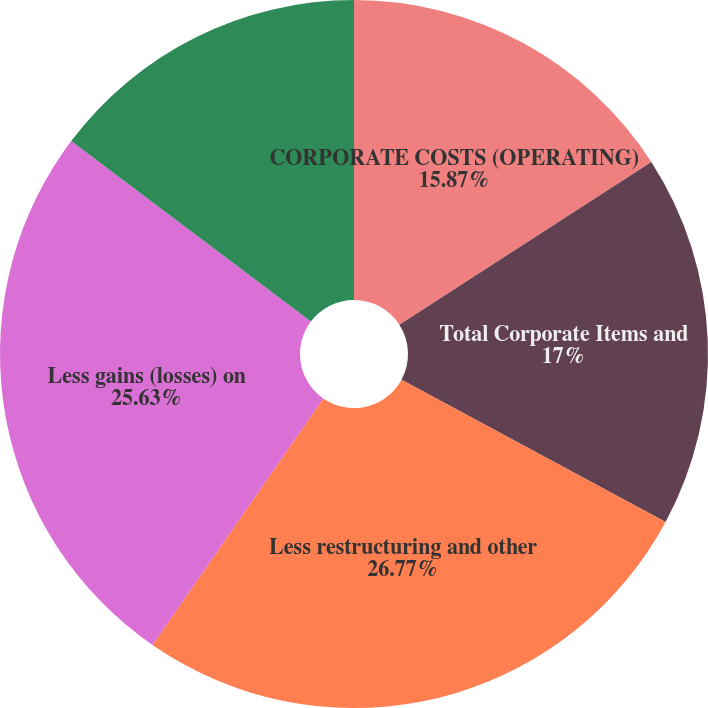Convert chart to OTSL. <chart><loc_0><loc_0><loc_500><loc_500><pie_chart><fcel>CORPORATE COSTS (OPERATING)<fcel>Total Corporate Items and<fcel>Less restructuring and other<fcel>Less gains (losses) on<fcel>Adjusted total corporate costs<nl><fcel>15.87%<fcel>17.0%<fcel>26.77%<fcel>25.63%<fcel>14.73%<nl></chart> 